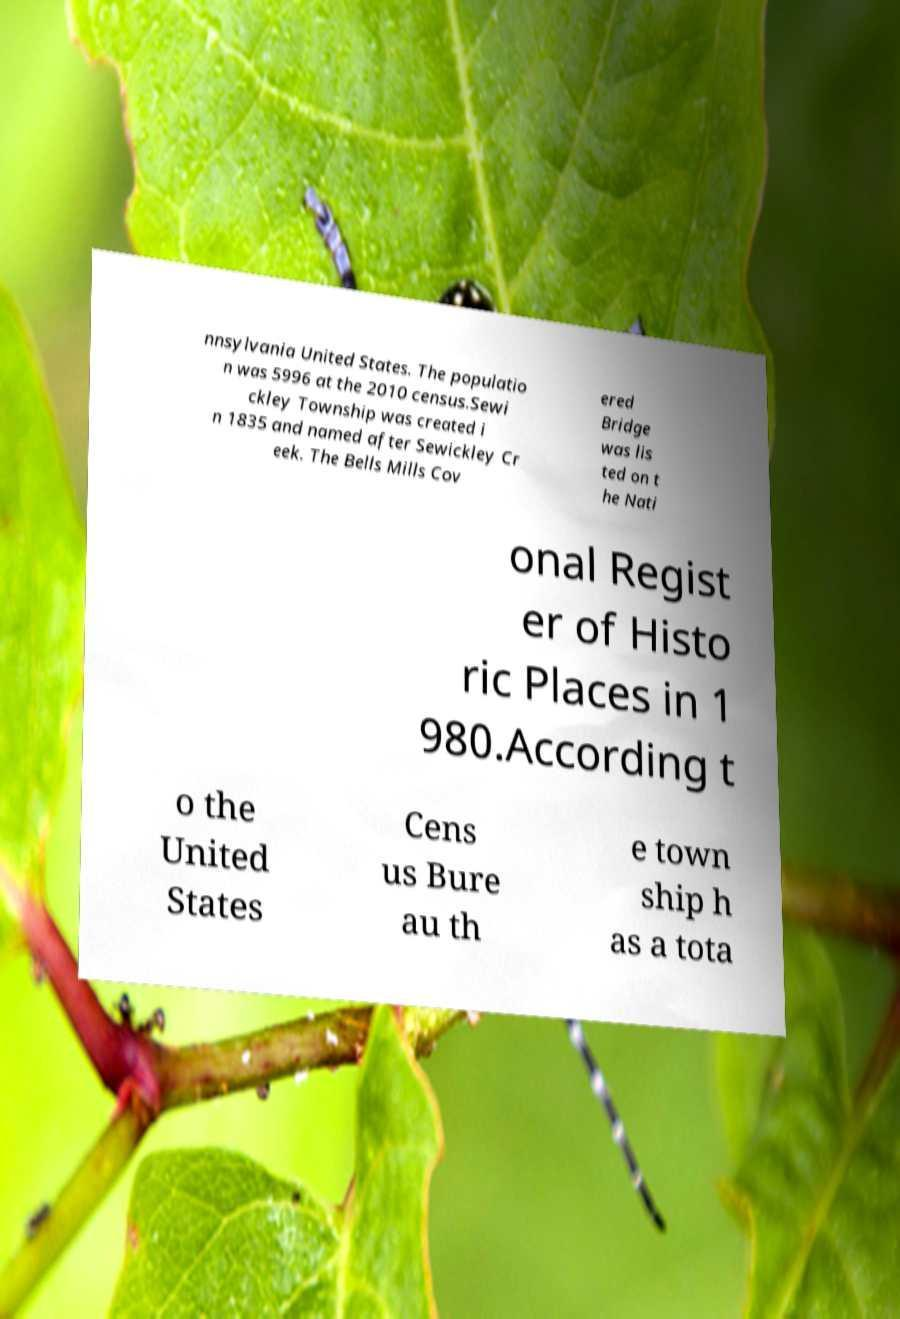Could you extract and type out the text from this image? nnsylvania United States. The populatio n was 5996 at the 2010 census.Sewi ckley Township was created i n 1835 and named after Sewickley Cr eek. The Bells Mills Cov ered Bridge was lis ted on t he Nati onal Regist er of Histo ric Places in 1 980.According t o the United States Cens us Bure au th e town ship h as a tota 